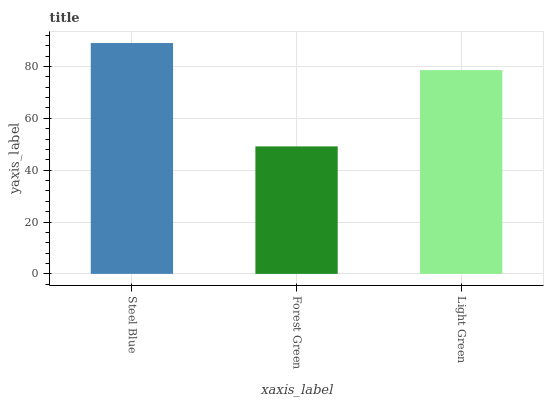Is Forest Green the minimum?
Answer yes or no. Yes. Is Steel Blue the maximum?
Answer yes or no. Yes. Is Light Green the minimum?
Answer yes or no. No. Is Light Green the maximum?
Answer yes or no. No. Is Light Green greater than Forest Green?
Answer yes or no. Yes. Is Forest Green less than Light Green?
Answer yes or no. Yes. Is Forest Green greater than Light Green?
Answer yes or no. No. Is Light Green less than Forest Green?
Answer yes or no. No. Is Light Green the high median?
Answer yes or no. Yes. Is Light Green the low median?
Answer yes or no. Yes. Is Forest Green the high median?
Answer yes or no. No. Is Steel Blue the low median?
Answer yes or no. No. 